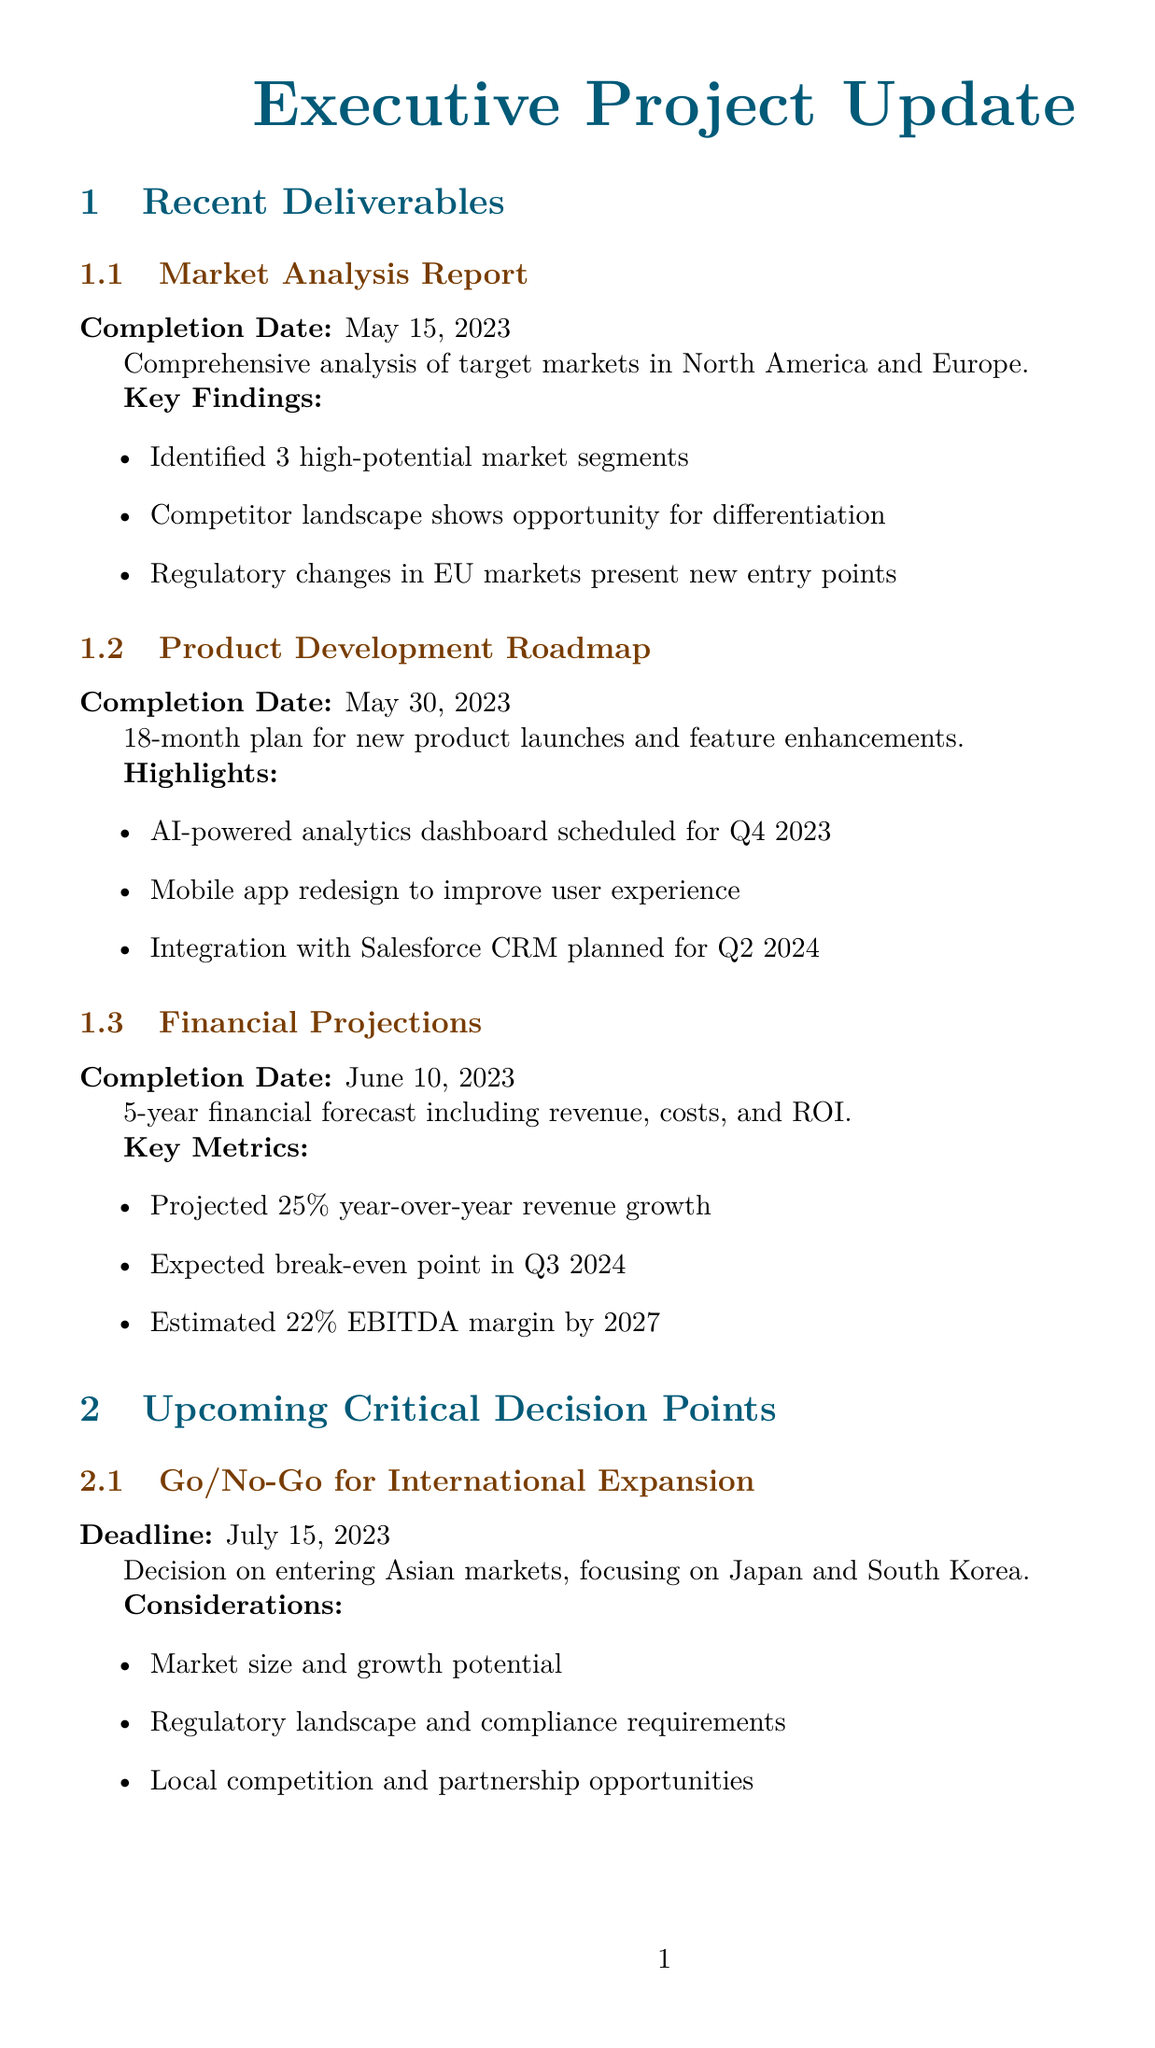What is the title of the most recent deliverable? The most recent deliverable is the first one listed under Recent Deliverables, which is the Market Analysis Report.
Answer: Market Analysis Report When was the Financial Projections report completed? The completion date of the Financial Projections report is specifically noted in the document.
Answer: June 10, 2023 What is the deadline for the Pricing Strategy Approval decision? The document specifies the deadline for Pricing Strategy Approval as a key upcoming critical decision point.
Answer: August 1, 2023 What is one of the key findings of the Market Analysis Report? The document includes a list of key findings within the Market Analysis Report.
Answer: Identified 3 high-potential market segments How many high-potential market segments were identified? A specific piece of information provided in the Market Analysis Report details the number of segments identified.
Answer: 3 What is the budget status of the project? The document summarizes the budget status of the project in one phrase.
Answer: Within allocated budget What potential risk involves talent acquisition? The document lists key risks, and one mentions challenges related to hiring for specific roles.
Answer: Talent acquisition challenges in AI/ML roles What is one decision point regarding technology? One of the critical decision points involves a proposal related to the technology stack upgrade.
Answer: Technology Stack Upgrade What should be the next step after the pricing strategy review? The next steps section outlines future actions following the pricing strategy review.
Answer: Initiate vendor evaluation process for cloud migration 